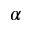<formula> <loc_0><loc_0><loc_500><loc_500>\alpha</formula> 